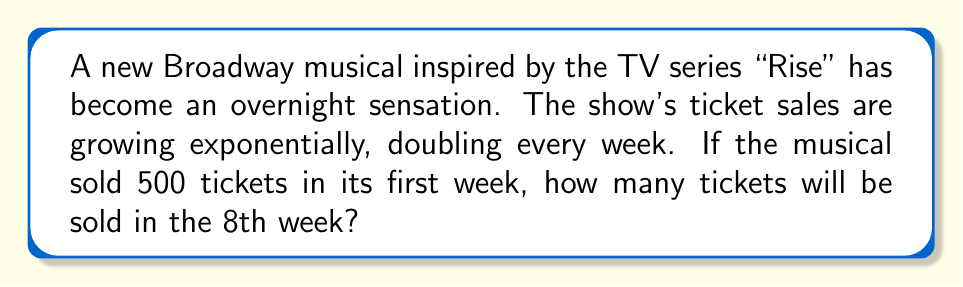What is the answer to this math problem? Let's approach this step-by-step:

1) We start with 500 tickets in the first week.
2) The number of tickets doubles every week, which means we're multiplying by 2 each time.
3) We need to find out how many times we multiply by 2 to get from week 1 to week 8.
   This is 7 times (because 8 - 1 = 7).
4) Mathematically, this can be expressed as:
   $500 \cdot 2^7$

5) Let's calculate $2^7$:
   $$2^7 = 2 \cdot 2 \cdot 2 \cdot 2 \cdot 2 \cdot 2 \cdot 2 = 128$$

6) Now we multiply this by our initial number of tickets:
   $$500 \cdot 128 = 64,000$$

Therefore, in the 8th week, the musical will sell 64,000 tickets.
Answer: 64,000 tickets 